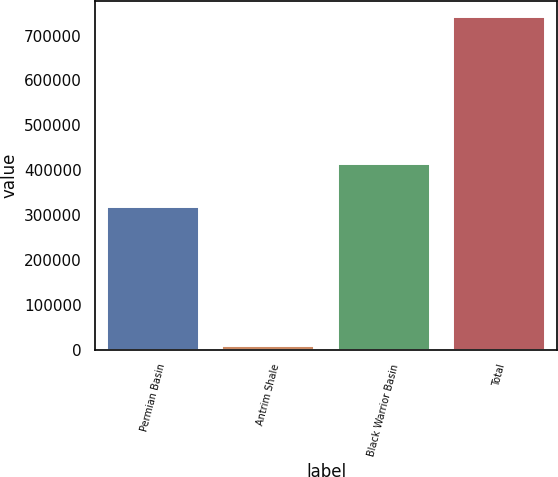Convert chart to OTSL. <chart><loc_0><loc_0><loc_500><loc_500><bar_chart><fcel>Permian Basin<fcel>Antrim Shale<fcel>Black Warrior Basin<fcel>Total<nl><fcel>318887<fcel>8262<fcel>413796<fcel>740945<nl></chart> 